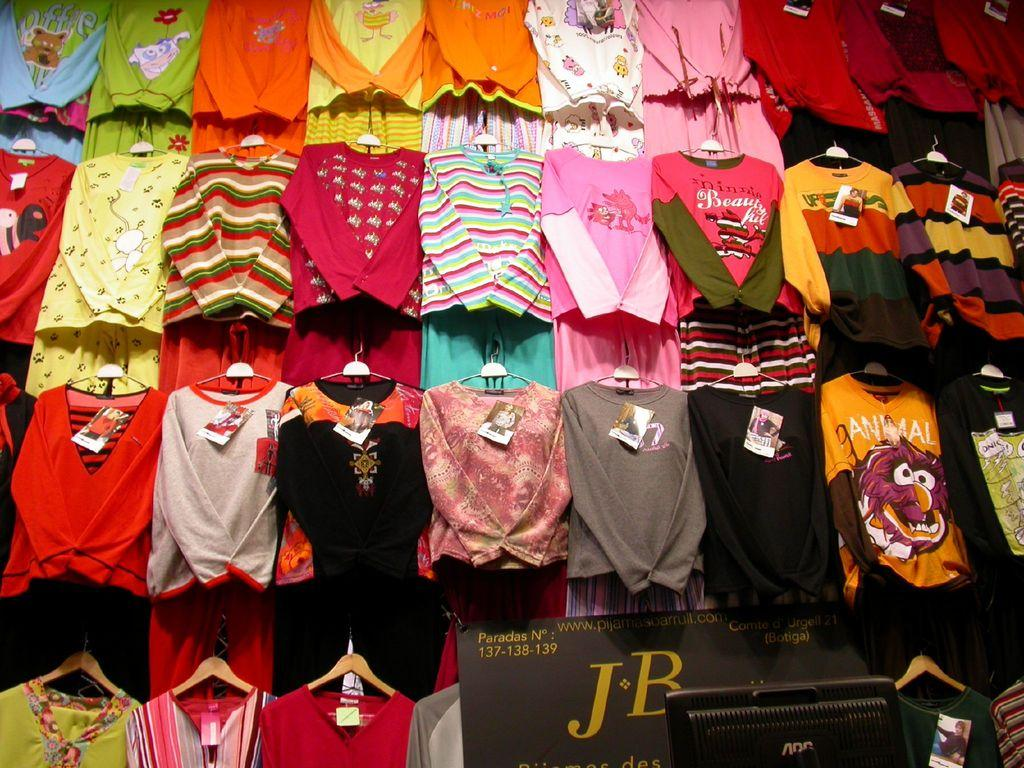What type of clothing items are hanging in the image? There are dresses hanging on hangers in the image. What piece of furniture is visible in the image? There is a desktop in the image. What is located at the bottom of the image? There is a board at the bottom of the image. What type of wax can be seen melting in the image? There is no wax present in the image. What kind of shade is covering the dresses in the image? There is no shade covering the dresses in the image; they are hanging on hangers in an open space. 